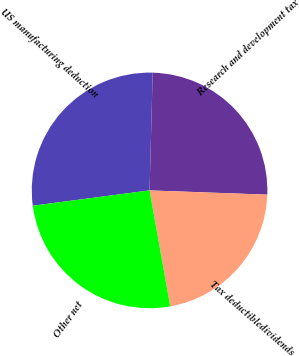Convert chart. <chart><loc_0><loc_0><loc_500><loc_500><pie_chart><fcel>US manufacturing deduction<fcel>Research and development tax<fcel>Tax deductibledividends<fcel>Other net<nl><fcel>27.5%<fcel>25.15%<fcel>21.62%<fcel>25.73%<nl></chart> 